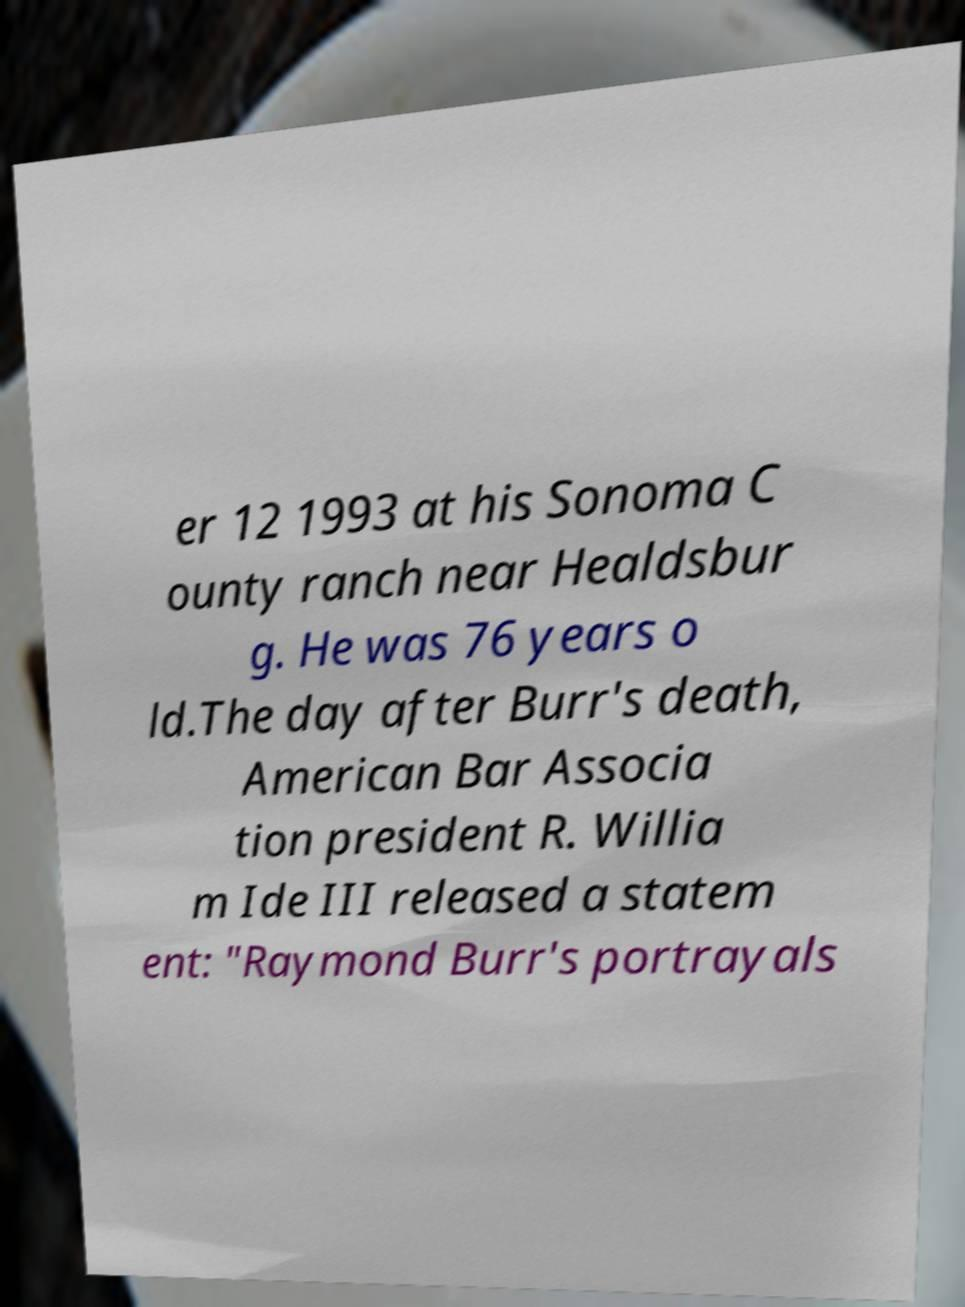Could you assist in decoding the text presented in this image and type it out clearly? er 12 1993 at his Sonoma C ounty ranch near Healdsbur g. He was 76 years o ld.The day after Burr's death, American Bar Associa tion president R. Willia m Ide III released a statem ent: "Raymond Burr's portrayals 